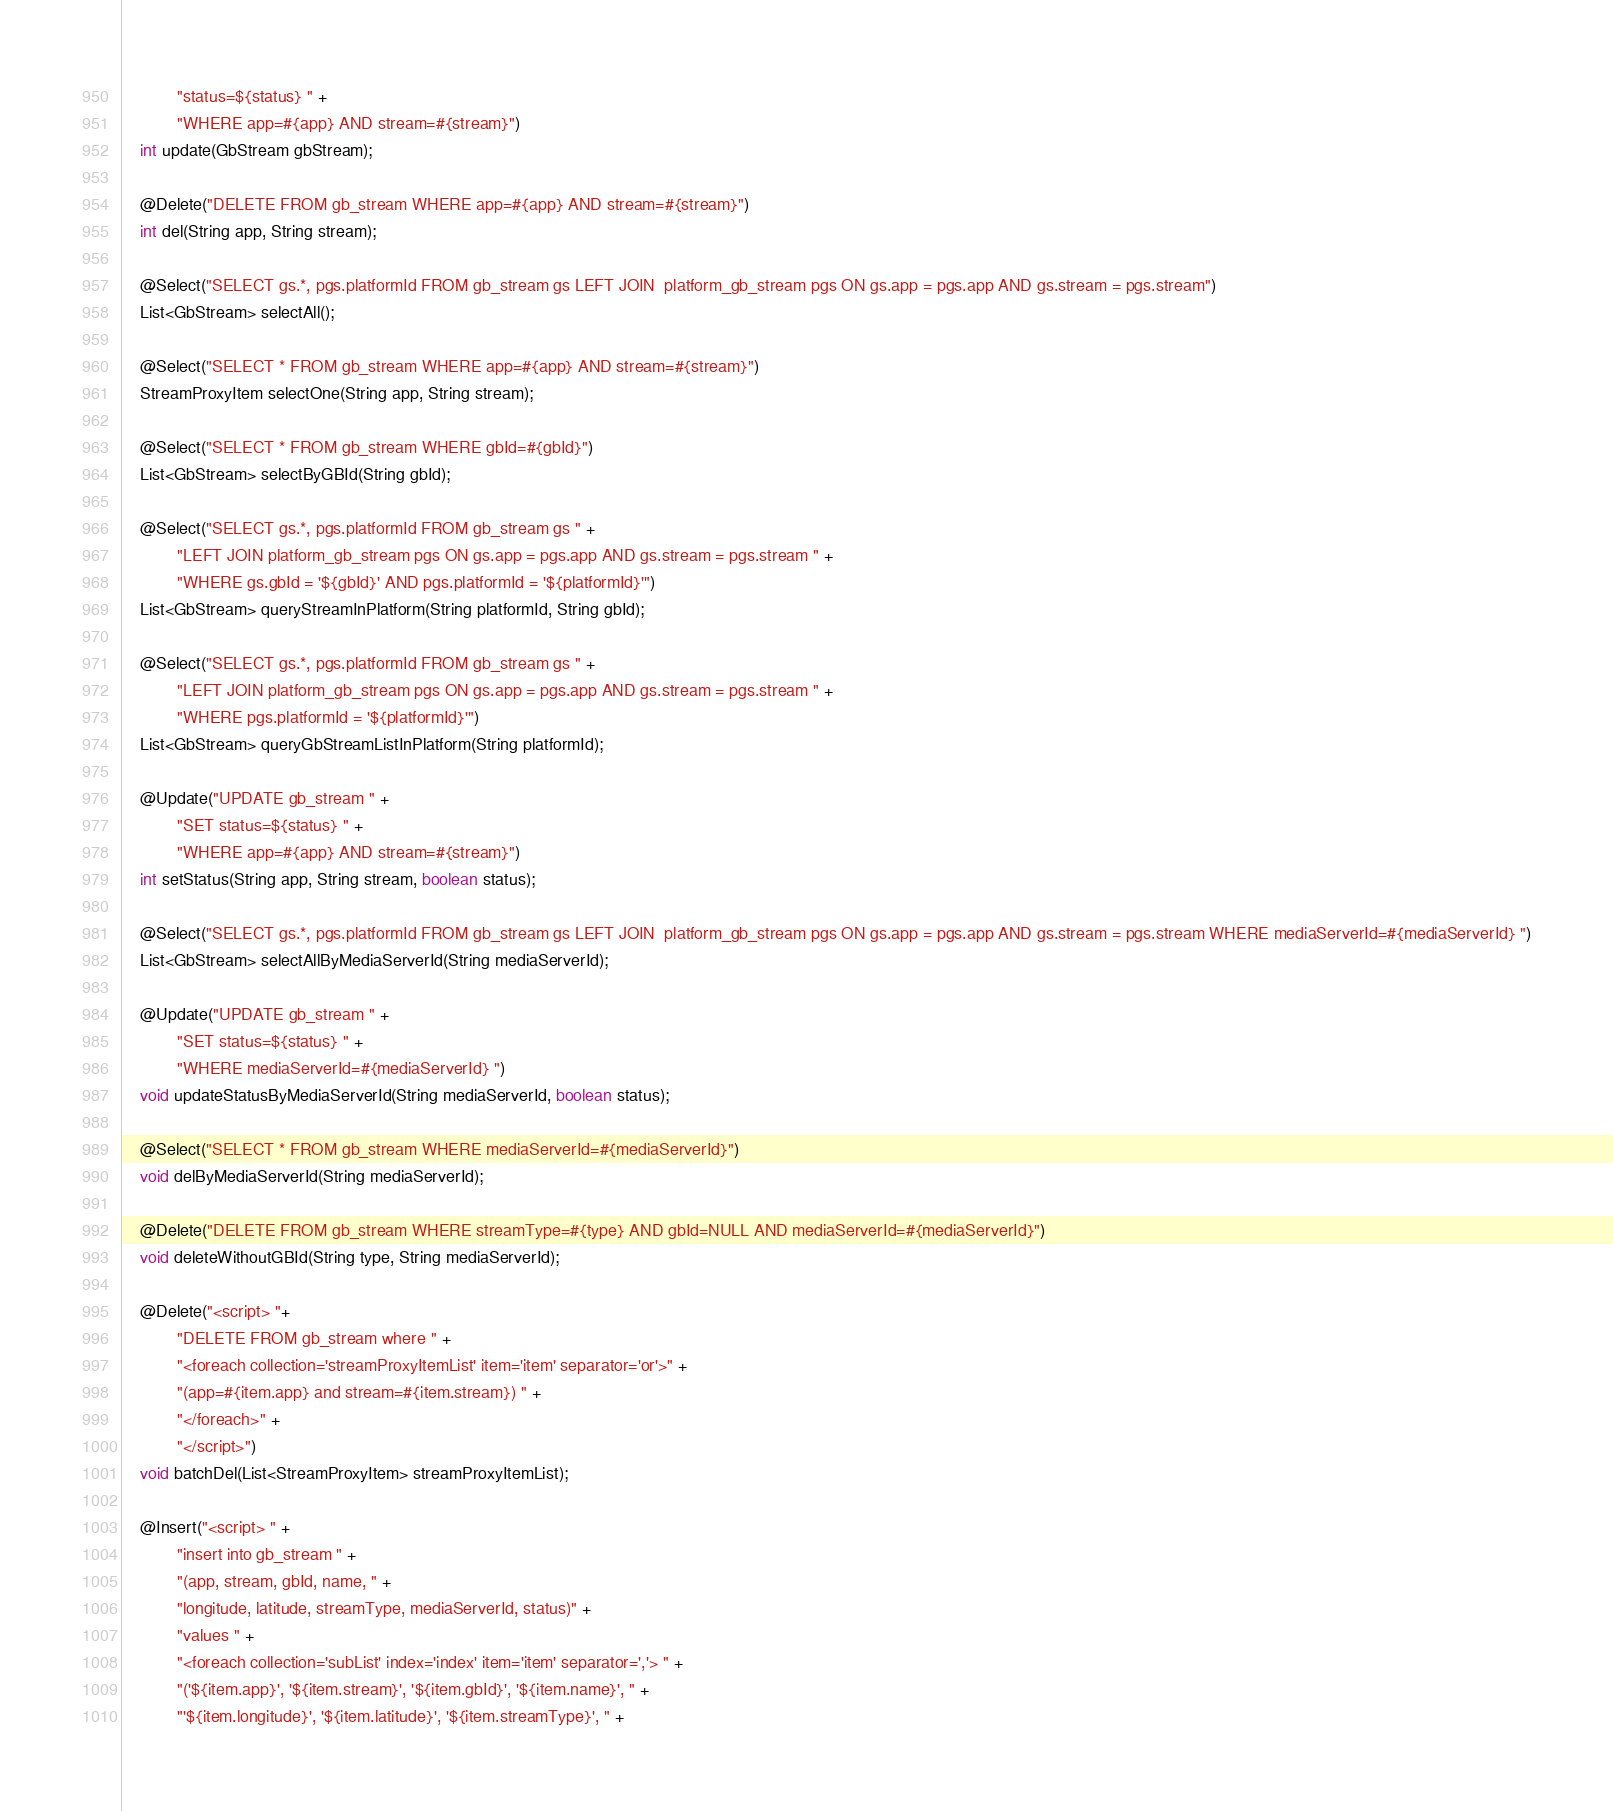<code> <loc_0><loc_0><loc_500><loc_500><_Java_>            "status=${status} " +
            "WHERE app=#{app} AND stream=#{stream}")
    int update(GbStream gbStream);

    @Delete("DELETE FROM gb_stream WHERE app=#{app} AND stream=#{stream}")
    int del(String app, String stream);

    @Select("SELECT gs.*, pgs.platformId FROM gb_stream gs LEFT JOIN  platform_gb_stream pgs ON gs.app = pgs.app AND gs.stream = pgs.stream")
    List<GbStream> selectAll();

    @Select("SELECT * FROM gb_stream WHERE app=#{app} AND stream=#{stream}")
    StreamProxyItem selectOne(String app, String stream);

    @Select("SELECT * FROM gb_stream WHERE gbId=#{gbId}")
    List<GbStream> selectByGBId(String gbId);

    @Select("SELECT gs.*, pgs.platformId FROM gb_stream gs " +
            "LEFT JOIN platform_gb_stream pgs ON gs.app = pgs.app AND gs.stream = pgs.stream " +
            "WHERE gs.gbId = '${gbId}' AND pgs.platformId = '${platformId}'")
    List<GbStream> queryStreamInPlatform(String platformId, String gbId);

    @Select("SELECT gs.*, pgs.platformId FROM gb_stream gs " +
            "LEFT JOIN platform_gb_stream pgs ON gs.app = pgs.app AND gs.stream = pgs.stream " +
            "WHERE pgs.platformId = '${platformId}'")
    List<GbStream> queryGbStreamListInPlatform(String platformId);

    @Update("UPDATE gb_stream " +
            "SET status=${status} " +
            "WHERE app=#{app} AND stream=#{stream}")
    int setStatus(String app, String stream, boolean status);

    @Select("SELECT gs.*, pgs.platformId FROM gb_stream gs LEFT JOIN  platform_gb_stream pgs ON gs.app = pgs.app AND gs.stream = pgs.stream WHERE mediaServerId=#{mediaServerId} ")
    List<GbStream> selectAllByMediaServerId(String mediaServerId);

    @Update("UPDATE gb_stream " +
            "SET status=${status} " +
            "WHERE mediaServerId=#{mediaServerId} ")
    void updateStatusByMediaServerId(String mediaServerId, boolean status);

    @Select("SELECT * FROM gb_stream WHERE mediaServerId=#{mediaServerId}")
    void delByMediaServerId(String mediaServerId);

    @Delete("DELETE FROM gb_stream WHERE streamType=#{type} AND gbId=NULL AND mediaServerId=#{mediaServerId}")
    void deleteWithoutGBId(String type, String mediaServerId);

    @Delete("<script> "+
            "DELETE FROM gb_stream where " +
            "<foreach collection='streamProxyItemList' item='item' separator='or'>" +
            "(app=#{item.app} and stream=#{item.stream}) " +
            "</foreach>" +
            "</script>")
    void batchDel(List<StreamProxyItem> streamProxyItemList);

    @Insert("<script> " +
            "insert into gb_stream " +
            "(app, stream, gbId, name, " +
            "longitude, latitude, streamType, mediaServerId, status)" +
            "values " +
            "<foreach collection='subList' index='index' item='item' separator=','> " +
            "('${item.app}', '${item.stream}', '${item.gbId}', '${item.name}', " +
            "'${item.longitude}', '${item.latitude}', '${item.streamType}', " +</code> 